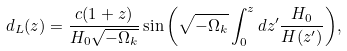Convert formula to latex. <formula><loc_0><loc_0><loc_500><loc_500>d _ { L } ( z ) = \frac { c ( 1 + z ) } { H _ { 0 } \sqrt { - \Omega _ { k } } } \sin { \left ( \sqrt { - \Omega _ { k } } \int _ { 0 } ^ { z } { d z ^ { \prime } \frac { H _ { 0 } } { H ( z ^ { \prime } ) } } \right ) } ,</formula> 